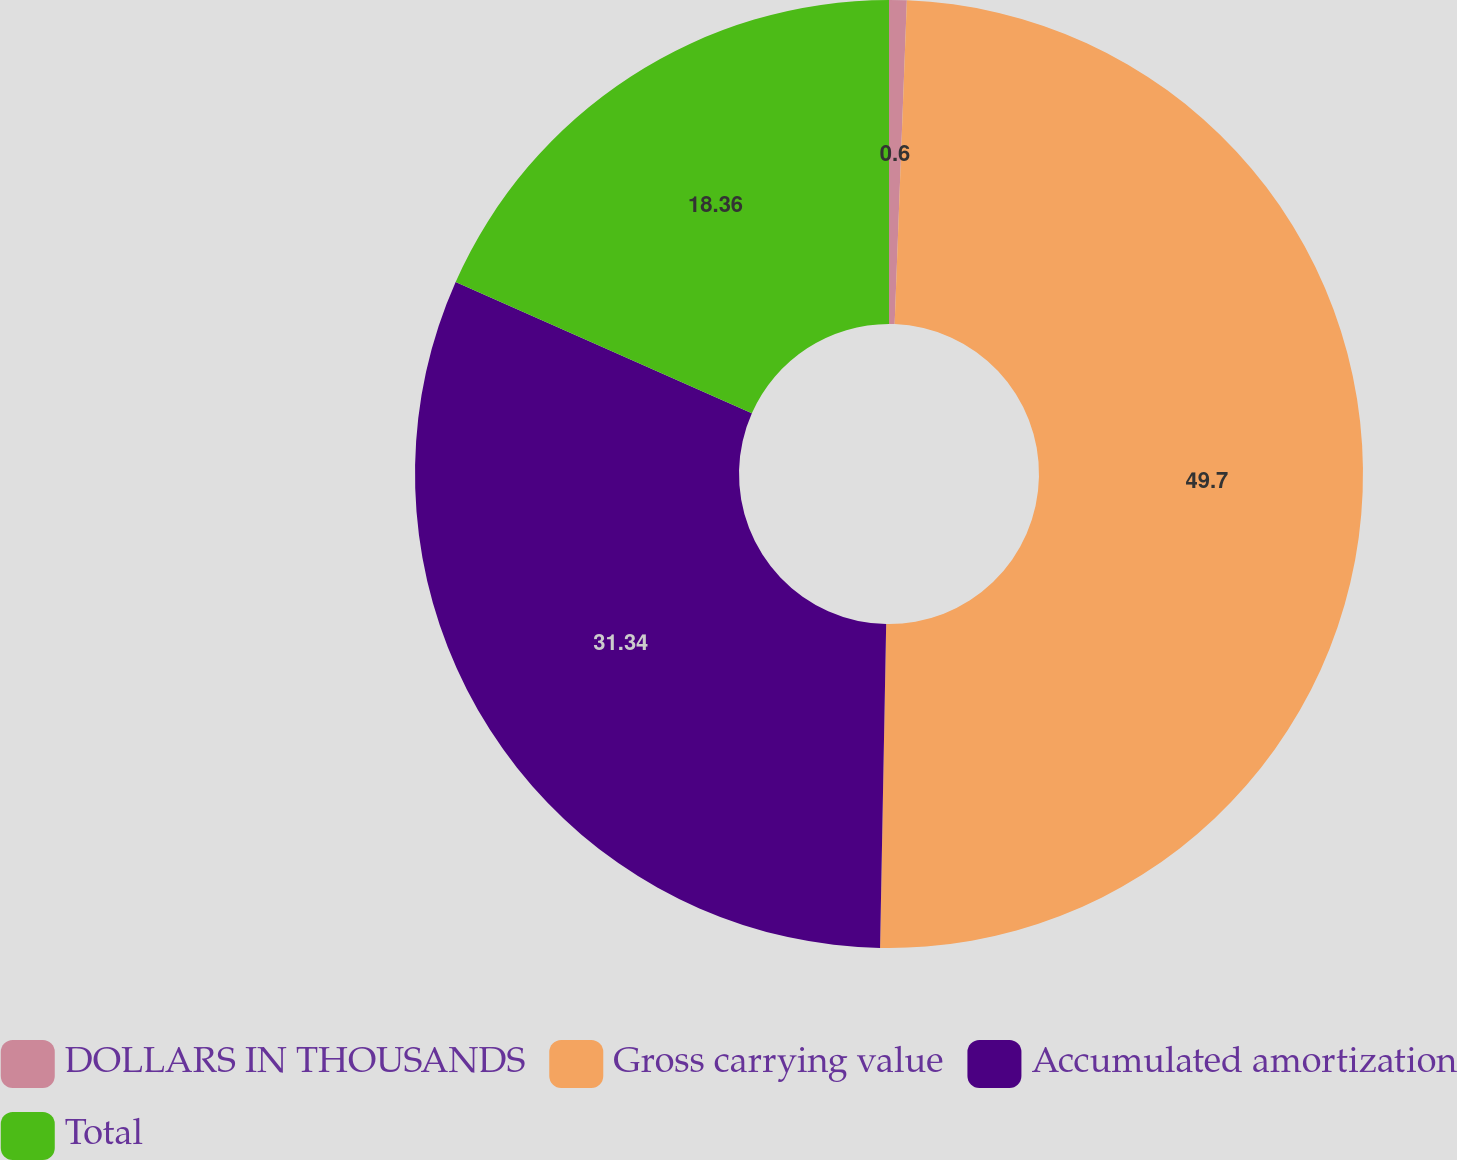<chart> <loc_0><loc_0><loc_500><loc_500><pie_chart><fcel>DOLLARS IN THOUSANDS<fcel>Gross carrying value<fcel>Accumulated amortization<fcel>Total<nl><fcel>0.6%<fcel>49.7%<fcel>31.34%<fcel>18.36%<nl></chart> 